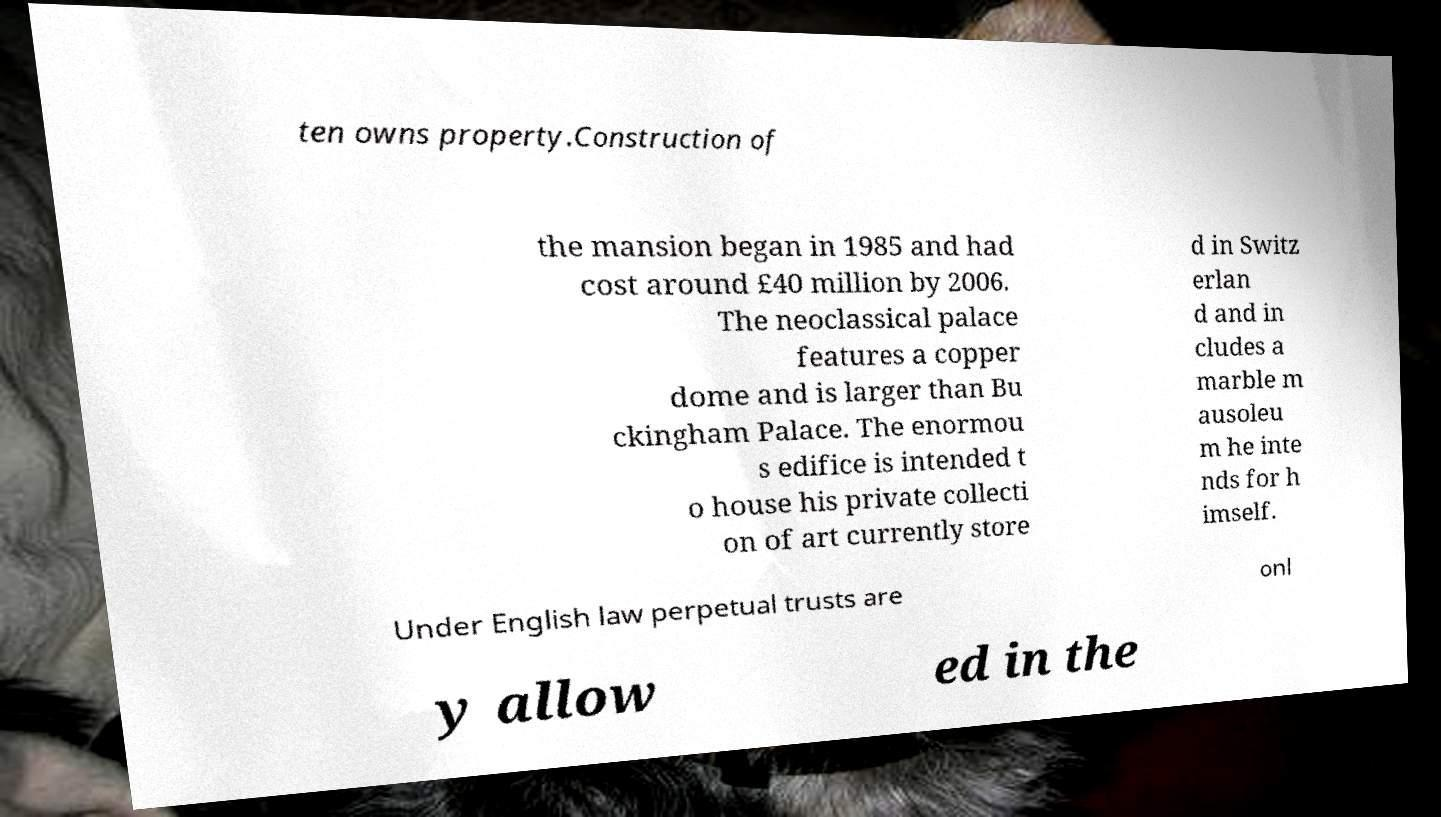I need the written content from this picture converted into text. Can you do that? ten owns property.Construction of the mansion began in 1985 and had cost around £40 million by 2006. The neoclassical palace features a copper dome and is larger than Bu ckingham Palace. The enormou s edifice is intended t o house his private collecti on of art currently store d in Switz erlan d and in cludes a marble m ausoleu m he inte nds for h imself. Under English law perpetual trusts are onl y allow ed in the 